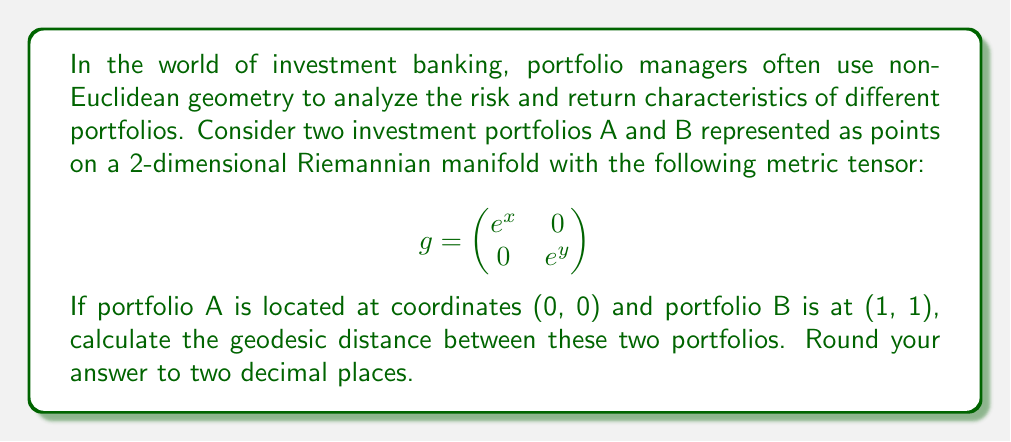Provide a solution to this math problem. To calculate the geodesic distance between two points on a Riemannian manifold, we need to use the following steps:

1. Determine the metric tensor $g_{ij}$. In this case, it's given as:

   $$g = \begin{pmatrix}
   e^x & 0 \\
   0 & e^y
   \end{pmatrix}$$

2. The geodesic distance is given by the integral:

   $$d(A,B) = \int_0^1 \sqrt{g_{ij}\frac{dx^i}{dt}\frac{dx^j}{dt}}dt$$

   where $x^i(t)$ represents the path from A to B parameterized by $t \in [0,1]$.

3. Assuming a straight line path between A(0,0) and B(1,1), we can parameterize it as:

   $x(t) = t$, $y(t) = t$, where $t \in [0,1]$

4. Calculate $\frac{dx}{dt} = 1$ and $\frac{dy}{dt} = 1$

5. Substitute into the integral:

   $$d(A,B) = \int_0^1 \sqrt{e^x\left(\frac{dx}{dt}\right)^2 + e^y\left(\frac{dy}{dt}\right)^2}dt$$
   $$= \int_0^1 \sqrt{e^t + e^t}dt = \int_0^1 \sqrt{2e^t}dt$$

6. Simplify:
   $$d(A,B) = \sqrt{2}\int_0^1 e^{t/2}dt$$

7. Integrate:
   $$d(A,B) = \sqrt{2}[2e^{t/2}]_0^1 = 2\sqrt{2}(e^{1/2} - 1)$$

8. Calculate and round to two decimal places:
   $$d(A,B) \approx 2.38$$
Answer: $2.38$ 